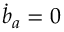Convert formula to latex. <formula><loc_0><loc_0><loc_500><loc_500>\dot { b } _ { a } = 0</formula> 